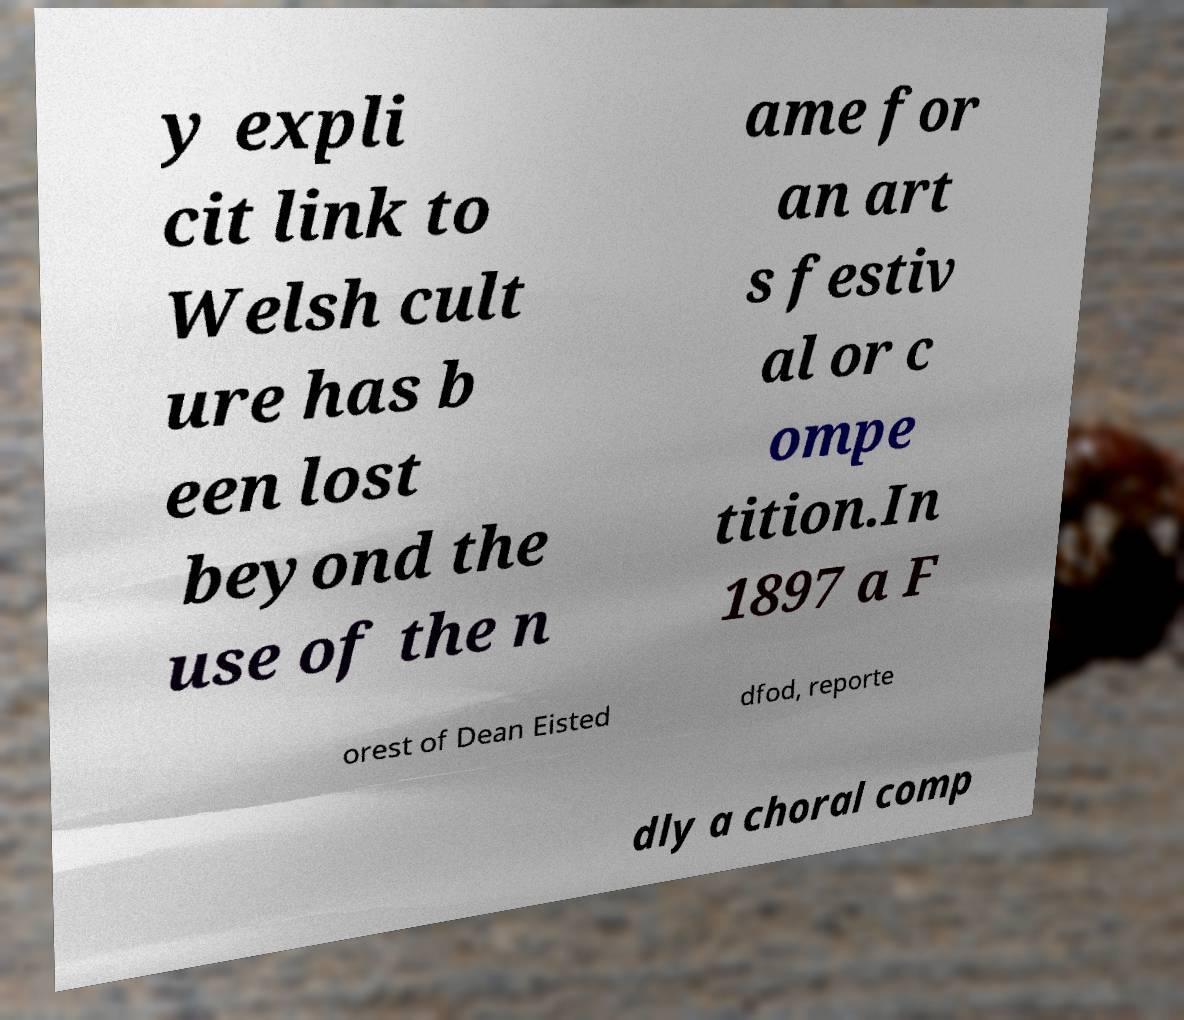What messages or text are displayed in this image? I need them in a readable, typed format. y expli cit link to Welsh cult ure has b een lost beyond the use of the n ame for an art s festiv al or c ompe tition.In 1897 a F orest of Dean Eisted dfod, reporte dly a choral comp 